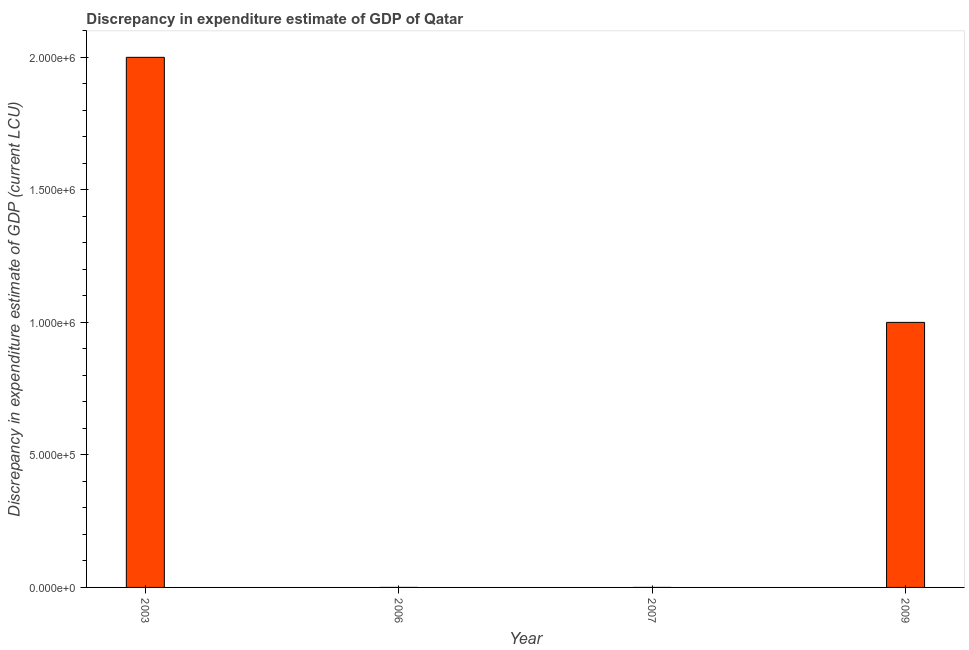Does the graph contain any zero values?
Give a very brief answer. Yes. What is the title of the graph?
Your answer should be compact. Discrepancy in expenditure estimate of GDP of Qatar. What is the label or title of the Y-axis?
Offer a very short reply. Discrepancy in expenditure estimate of GDP (current LCU). Across all years, what is the maximum discrepancy in expenditure estimate of gdp?
Give a very brief answer. 2.00e+06. What is the sum of the discrepancy in expenditure estimate of gdp?
Offer a very short reply. 3.00e+06. What is the average discrepancy in expenditure estimate of gdp per year?
Keep it short and to the point. 7.50e+05. What is the median discrepancy in expenditure estimate of gdp?
Give a very brief answer. 5.00e+05. In how many years, is the discrepancy in expenditure estimate of gdp greater than 100000 LCU?
Offer a terse response. 2. Is the difference between the discrepancy in expenditure estimate of gdp in 2003 and 2009 greater than the difference between any two years?
Provide a short and direct response. No. Is the sum of the discrepancy in expenditure estimate of gdp in 2003 and 2009 greater than the maximum discrepancy in expenditure estimate of gdp across all years?
Provide a short and direct response. Yes. What is the difference between the highest and the lowest discrepancy in expenditure estimate of gdp?
Provide a succinct answer. 2.00e+06. In how many years, is the discrepancy in expenditure estimate of gdp greater than the average discrepancy in expenditure estimate of gdp taken over all years?
Your answer should be very brief. 2. Are all the bars in the graph horizontal?
Make the answer very short. No. How many years are there in the graph?
Provide a short and direct response. 4. Are the values on the major ticks of Y-axis written in scientific E-notation?
Keep it short and to the point. Yes. What is the Discrepancy in expenditure estimate of GDP (current LCU) in 2003?
Offer a very short reply. 2.00e+06. What is the Discrepancy in expenditure estimate of GDP (current LCU) in 2006?
Provide a succinct answer. 0. What is the Discrepancy in expenditure estimate of GDP (current LCU) of 2009?
Offer a terse response. 1.00e+06. What is the difference between the Discrepancy in expenditure estimate of GDP (current LCU) in 2003 and 2009?
Ensure brevity in your answer.  1.00e+06. What is the ratio of the Discrepancy in expenditure estimate of GDP (current LCU) in 2003 to that in 2009?
Ensure brevity in your answer.  2. 